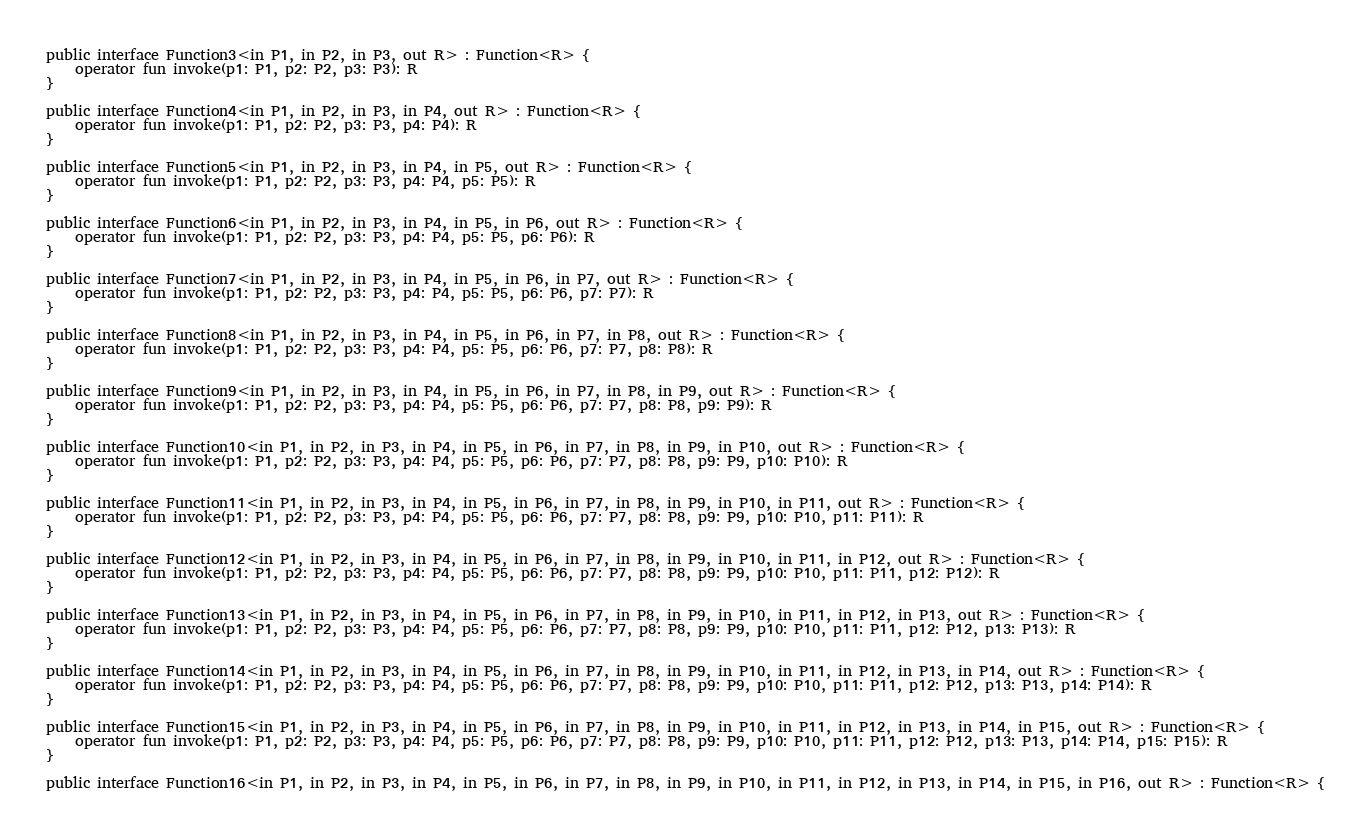Convert code to text. <code><loc_0><loc_0><loc_500><loc_500><_Kotlin_>public interface Function3<in P1, in P2, in P3, out R> : Function<R> {
    operator fun invoke(p1: P1, p2: P2, p3: P3): R
}

public interface Function4<in P1, in P2, in P3, in P4, out R> : Function<R> {
    operator fun invoke(p1: P1, p2: P2, p3: P3, p4: P4): R
}

public interface Function5<in P1, in P2, in P3, in P4, in P5, out R> : Function<R> {
    operator fun invoke(p1: P1, p2: P2, p3: P3, p4: P4, p5: P5): R
}

public interface Function6<in P1, in P2, in P3, in P4, in P5, in P6, out R> : Function<R> {
    operator fun invoke(p1: P1, p2: P2, p3: P3, p4: P4, p5: P5, p6: P6): R
}

public interface Function7<in P1, in P2, in P3, in P4, in P5, in P6, in P7, out R> : Function<R> {
    operator fun invoke(p1: P1, p2: P2, p3: P3, p4: P4, p5: P5, p6: P6, p7: P7): R
}

public interface Function8<in P1, in P2, in P3, in P4, in P5, in P6, in P7, in P8, out R> : Function<R> {
    operator fun invoke(p1: P1, p2: P2, p3: P3, p4: P4, p5: P5, p6: P6, p7: P7, p8: P8): R
}

public interface Function9<in P1, in P2, in P3, in P4, in P5, in P6, in P7, in P8, in P9, out R> : Function<R> {
    operator fun invoke(p1: P1, p2: P2, p3: P3, p4: P4, p5: P5, p6: P6, p7: P7, p8: P8, p9: P9): R
}

public interface Function10<in P1, in P2, in P3, in P4, in P5, in P6, in P7, in P8, in P9, in P10, out R> : Function<R> {
    operator fun invoke(p1: P1, p2: P2, p3: P3, p4: P4, p5: P5, p6: P6, p7: P7, p8: P8, p9: P9, p10: P10): R
}

public interface Function11<in P1, in P2, in P3, in P4, in P5, in P6, in P7, in P8, in P9, in P10, in P11, out R> : Function<R> {
    operator fun invoke(p1: P1, p2: P2, p3: P3, p4: P4, p5: P5, p6: P6, p7: P7, p8: P8, p9: P9, p10: P10, p11: P11): R
}

public interface Function12<in P1, in P2, in P3, in P4, in P5, in P6, in P7, in P8, in P9, in P10, in P11, in P12, out R> : Function<R> {
    operator fun invoke(p1: P1, p2: P2, p3: P3, p4: P4, p5: P5, p6: P6, p7: P7, p8: P8, p9: P9, p10: P10, p11: P11, p12: P12): R
}

public interface Function13<in P1, in P2, in P3, in P4, in P5, in P6, in P7, in P8, in P9, in P10, in P11, in P12, in P13, out R> : Function<R> {
    operator fun invoke(p1: P1, p2: P2, p3: P3, p4: P4, p5: P5, p6: P6, p7: P7, p8: P8, p9: P9, p10: P10, p11: P11, p12: P12, p13: P13): R
}

public interface Function14<in P1, in P2, in P3, in P4, in P5, in P6, in P7, in P8, in P9, in P10, in P11, in P12, in P13, in P14, out R> : Function<R> {
    operator fun invoke(p1: P1, p2: P2, p3: P3, p4: P4, p5: P5, p6: P6, p7: P7, p8: P8, p9: P9, p10: P10, p11: P11, p12: P12, p13: P13, p14: P14): R
}

public interface Function15<in P1, in P2, in P3, in P4, in P5, in P6, in P7, in P8, in P9, in P10, in P11, in P12, in P13, in P14, in P15, out R> : Function<R> {
    operator fun invoke(p1: P1, p2: P2, p3: P3, p4: P4, p5: P5, p6: P6, p7: P7, p8: P8, p9: P9, p10: P10, p11: P11, p12: P12, p13: P13, p14: P14, p15: P15): R
}

public interface Function16<in P1, in P2, in P3, in P4, in P5, in P6, in P7, in P8, in P9, in P10, in P11, in P12, in P13, in P14, in P15, in P16, out R> : Function<R> {</code> 